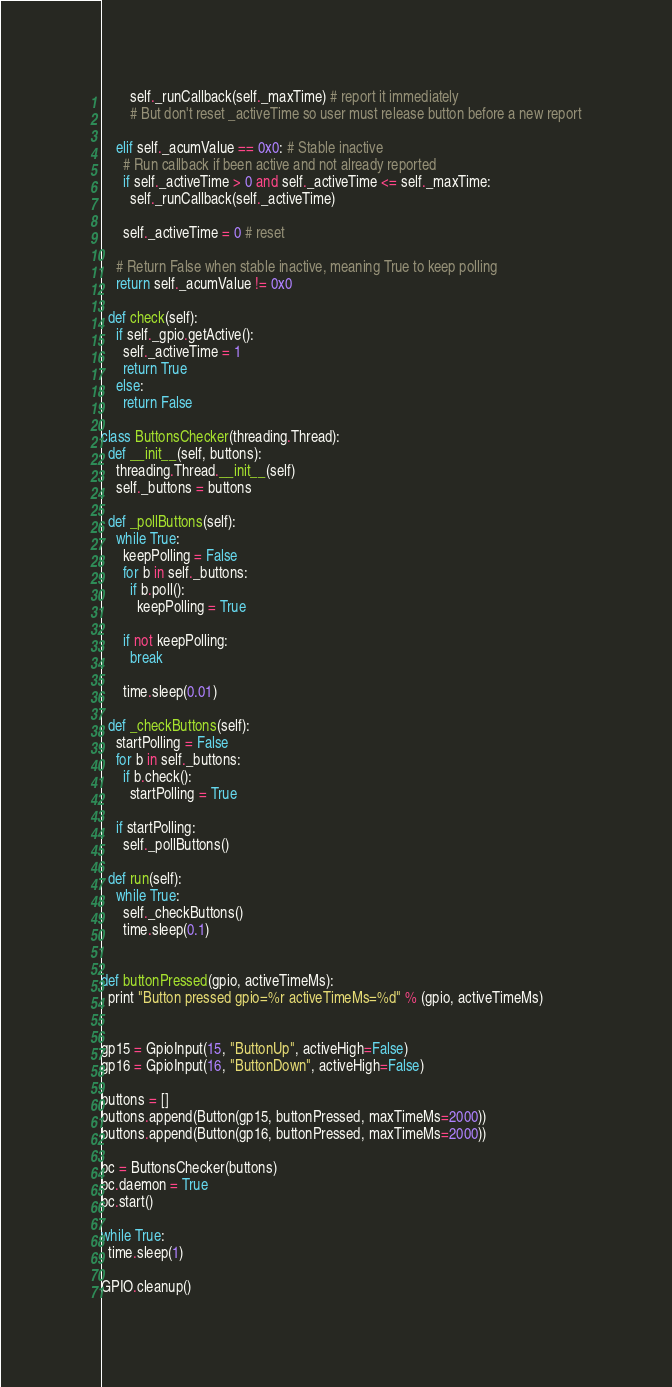Convert code to text. <code><loc_0><loc_0><loc_500><loc_500><_Python_>        self._runCallback(self._maxTime) # report it immediately
        # But don't reset _activeTime so user must release button before a new report

    elif self._acumValue == 0x0: # Stable inactive
      # Run callback if been active and not already reported
      if self._activeTime > 0 and self._activeTime <= self._maxTime: 
        self._runCallback(self._activeTime)        
      
      self._activeTime = 0 # reset
      
    # Return False when stable inactive, meaning True to keep polling
    return self._acumValue != 0x0
    
  def check(self):
    if self._gpio.getActive():
      self._activeTime = 1
      return True
    else:      
      return False

class ButtonsChecker(threading.Thread):
  def __init__(self, buttons):
    threading.Thread.__init__(self)
    self._buttons = buttons

  def _pollButtons(self):
    while True:
      keepPolling = False
      for b in self._buttons:
        if b.poll():
          keepPolling = True
        
      if not keepPolling:
        break

      time.sleep(0.01)

  def _checkButtons(self):
    startPolling = False
    for b in self._buttons:
      if b.check():
        startPolling = True
      
    if startPolling:
      self._pollButtons()

  def run(self):
    while True:
      self._checkButtons()
      time.sleep(0.1)    


def buttonPressed(gpio, activeTimeMs):
  print "Button pressed gpio=%r activeTimeMs=%d" % (gpio, activeTimeMs)


gp15 = GpioInput(15, "ButtonUp", activeHigh=False)
gp16 = GpioInput(16, "ButtonDown", activeHigh=False)

buttons = []
buttons.append(Button(gp15, buttonPressed, maxTimeMs=2000))
buttons.append(Button(gp16, buttonPressed, maxTimeMs=2000))

bc = ButtonsChecker(buttons)
bc.daemon = True
bc.start()

while True:
  time.sleep(1)
  
GPIO.cleanup()
</code> 